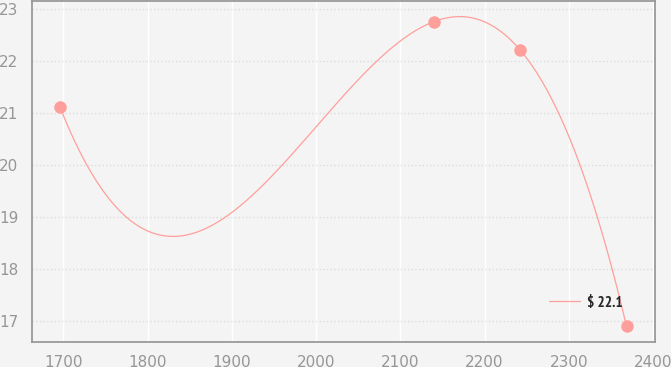<chart> <loc_0><loc_0><loc_500><loc_500><line_chart><ecel><fcel>$ 22.1<nl><fcel>1695.74<fcel>21.12<nl><fcel>2139.41<fcel>22.76<nl><fcel>2242.63<fcel>22.21<nl><fcel>2368.66<fcel>16.89<nl></chart> 